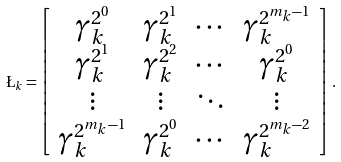<formula> <loc_0><loc_0><loc_500><loc_500>\L _ { k } = \left [ \begin{array} { c c c c } \gamma _ { k } ^ { 2 ^ { 0 } } & \gamma _ { k } ^ { 2 ^ { 1 } } & \cdots & \gamma _ { k } ^ { 2 ^ { m _ { k } - 1 } } \\ \gamma _ { k } ^ { 2 ^ { 1 } } & \gamma _ { k } ^ { 2 ^ { 2 } } & \cdots & \gamma _ { k } ^ { 2 ^ { 0 } } \\ \vdots & \vdots & \ddots & \vdots \\ \gamma _ { k } ^ { 2 ^ { m _ { k } - 1 } } & \gamma _ { k } ^ { 2 ^ { 0 } } & \cdots & \gamma _ { k } ^ { 2 ^ { m _ { k } - 2 } } \end{array} \right ] .</formula> 